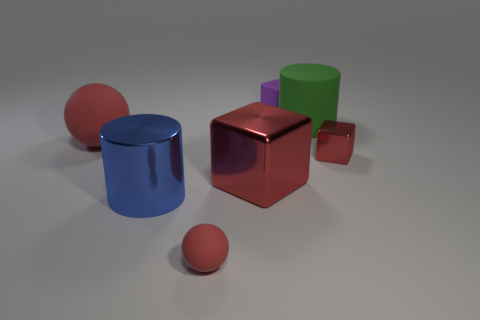Is there a red shiny object that has the same shape as the tiny purple thing?
Your response must be concise. Yes. What material is the large blue cylinder?
Keep it short and to the point. Metal. Are there any metal objects left of the green cylinder?
Provide a short and direct response. Yes. Do the green matte object and the large blue metallic thing have the same shape?
Provide a short and direct response. Yes. How many other objects are there of the same size as the shiny cylinder?
Give a very brief answer. 3. How many things are either large things that are behind the large matte sphere or large red matte objects?
Your answer should be very brief. 2. What is the color of the matte block?
Provide a succinct answer. Purple. What material is the ball that is left of the tiny rubber sphere?
Provide a short and direct response. Rubber. There is a large red metallic object; does it have the same shape as the big object that is in front of the large cube?
Give a very brief answer. No. Are there more large brown metallic cylinders than large cylinders?
Provide a succinct answer. No. 